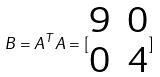<formula> <loc_0><loc_0><loc_500><loc_500>B = A ^ { T } A = [ \begin{matrix} 9 & 0 \\ 0 & 4 \end{matrix} ]</formula> 